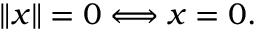Convert formula to latex. <formula><loc_0><loc_0><loc_500><loc_500>\| x \| = 0 \Longleftrightarrow x = 0 .</formula> 